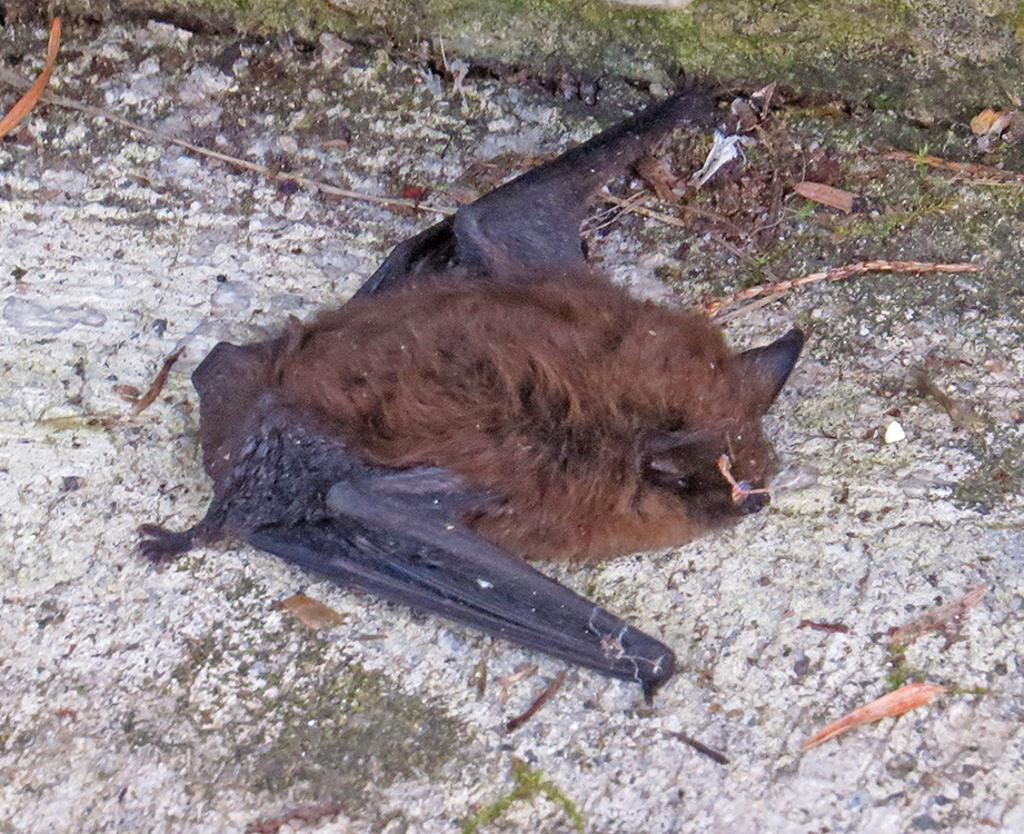What type of creature is present in the image? There is an animal in the image. What is the animal doing in the image? The animal is sleeping. Where is the animal located in the image? The animal is on the ground. What type of needle can be seen in the image? There is no needle present in the image. Can you describe the window in the image? There is no window present in the image. 